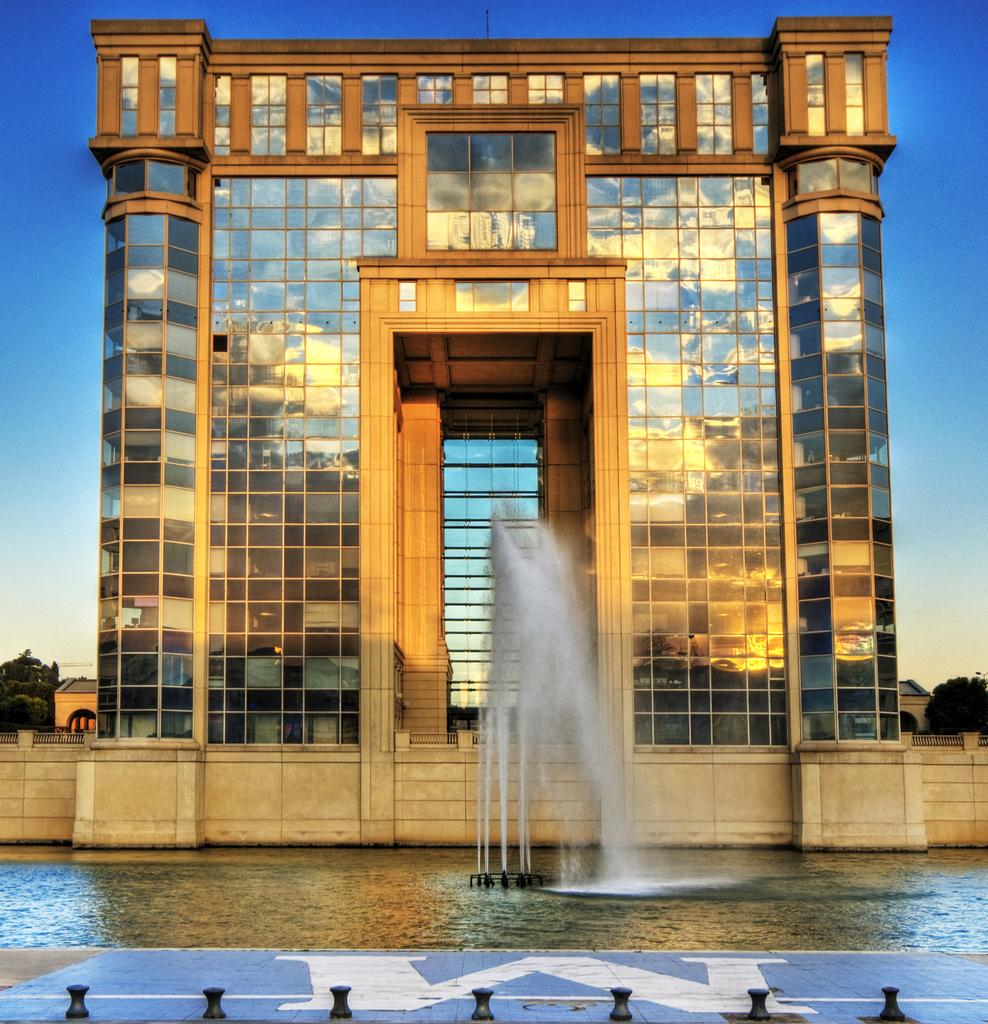What type of structure is present in the image? There is a building in the image. What can be seen at the bottom of the image? There is a fountain at the bottom of the image. What is visible at the top of the image? The sky is visible at the top of the image. What type of skate is being used to perform tricks in the image? There is no skate present in the image; it features a building and a fountain. How does the bomb affect the building in the image? There is no bomb present in the image; it features a building and a fountain. 